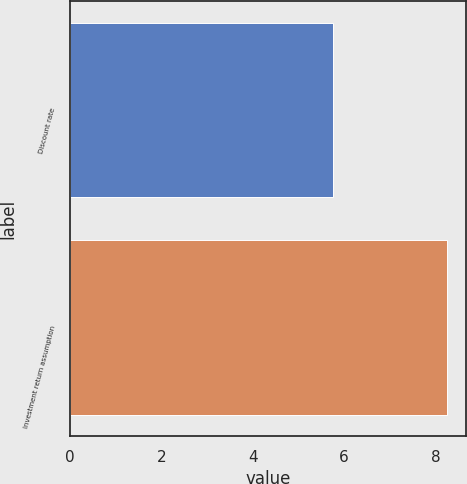<chart> <loc_0><loc_0><loc_500><loc_500><bar_chart><fcel>Discount rate<fcel>Investment return assumption<nl><fcel>5.75<fcel>8.25<nl></chart> 